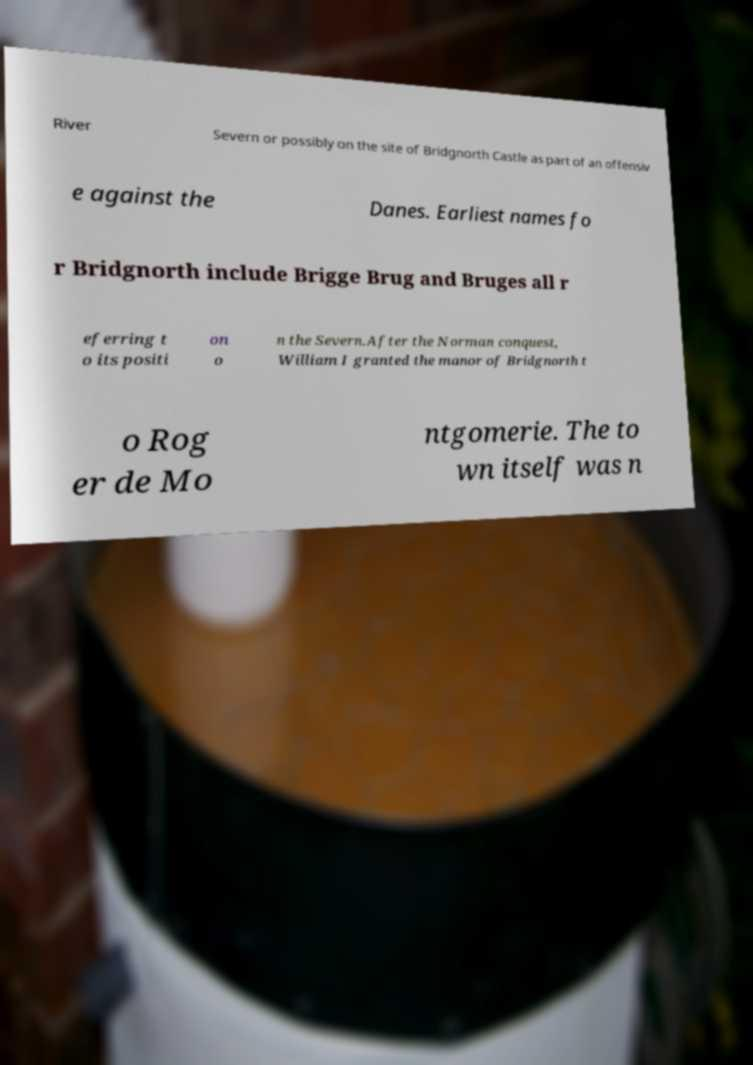Can you accurately transcribe the text from the provided image for me? River Severn or possibly on the site of Bridgnorth Castle as part of an offensiv e against the Danes. Earliest names fo r Bridgnorth include Brigge Brug and Bruges all r eferring t o its positi on o n the Severn.After the Norman conquest, William I granted the manor of Bridgnorth t o Rog er de Mo ntgomerie. The to wn itself was n 